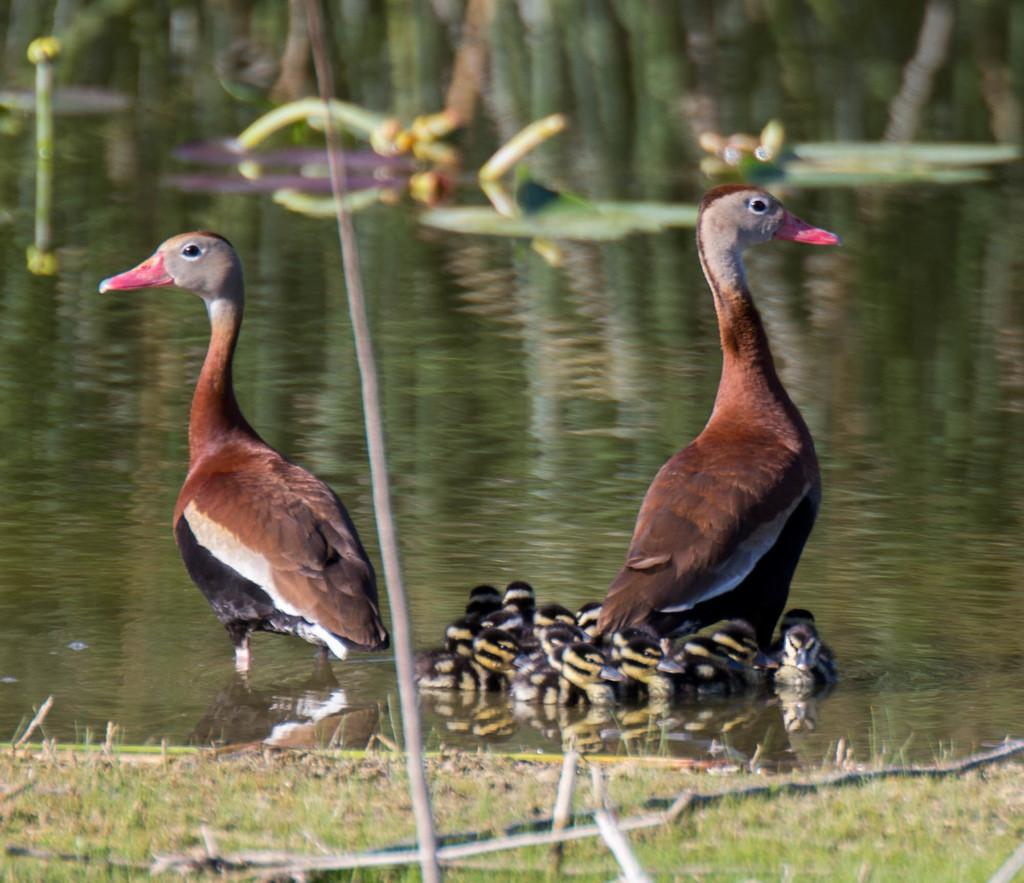How many ducks are present in the image? There are 2 ducks in the image. What is the color of the ducks? The ducks are brown in color. Are there any baby ducks in the image? Yes, there are ducklings in the image. What are the ducklings doing in the image? The ducklings are swimming in the water. What type of joke is the duck telling in the image? There is no indication in the image that the duck is telling a joke, as ducks do not have the ability to speak or tell jokes. 